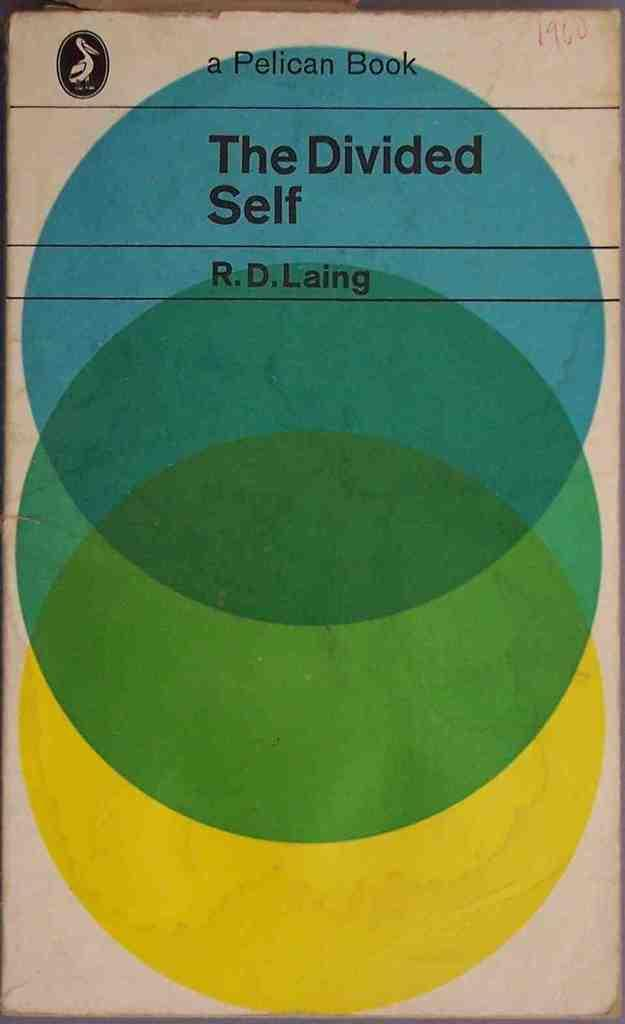<image>
Summarize the visual content of the image. A book cover has the title The Divided Self inside a blue circle. 